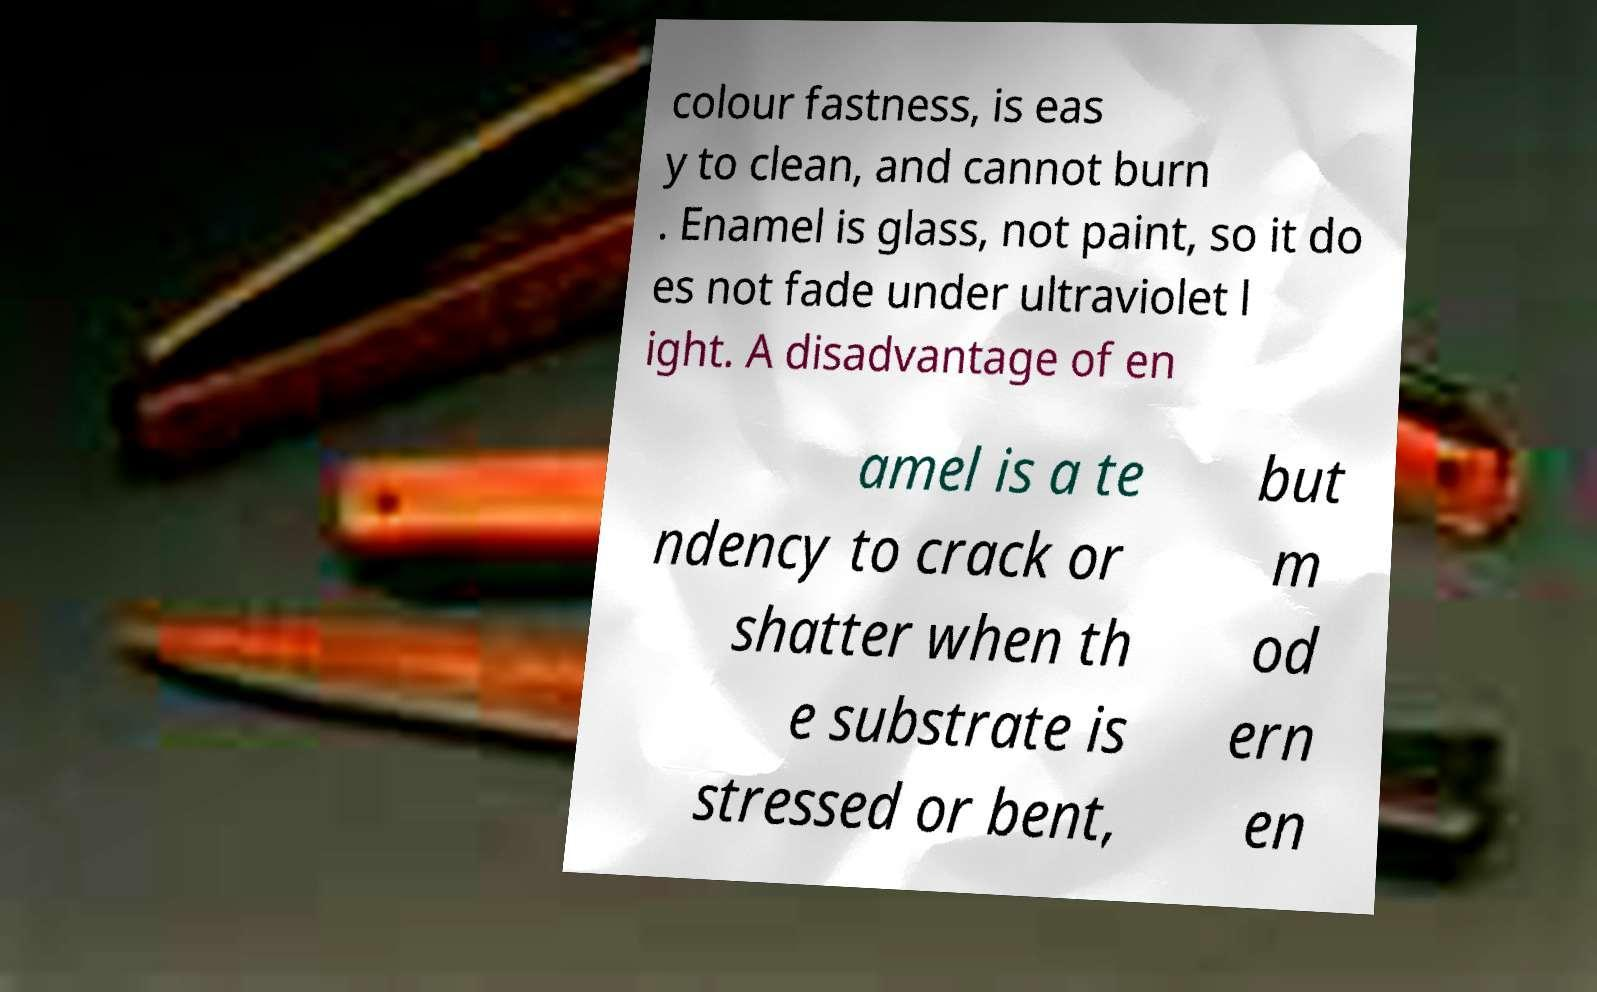I need the written content from this picture converted into text. Can you do that? colour fastness, is eas y to clean, and cannot burn . Enamel is glass, not paint, so it do es not fade under ultraviolet l ight. A disadvantage of en amel is a te ndency to crack or shatter when th e substrate is stressed or bent, but m od ern en 